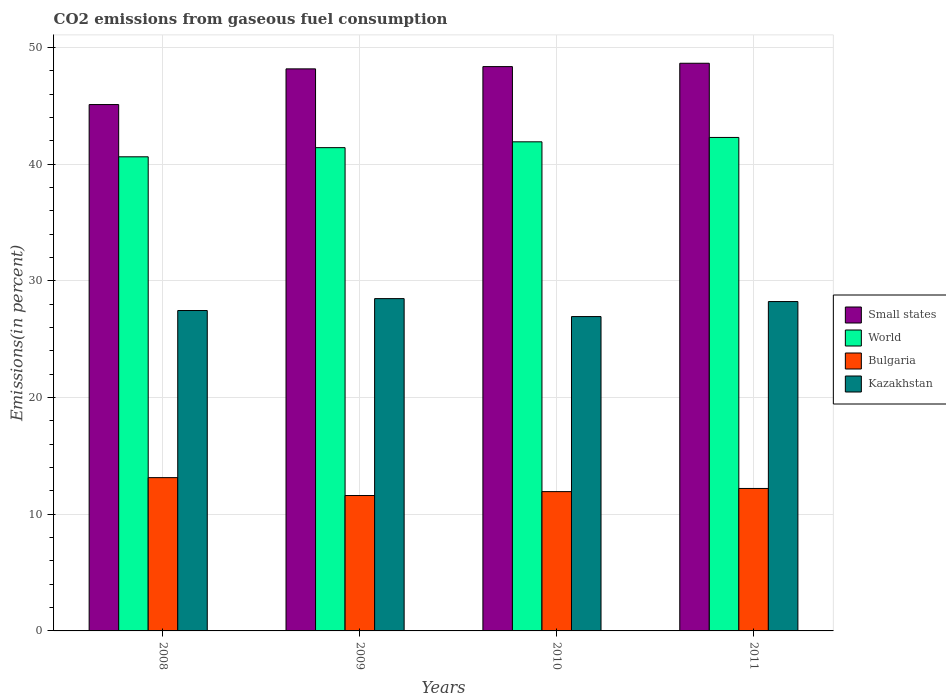Are the number of bars per tick equal to the number of legend labels?
Your answer should be compact. Yes. In how many cases, is the number of bars for a given year not equal to the number of legend labels?
Your response must be concise. 0. What is the total CO2 emitted in Kazakhstan in 2010?
Ensure brevity in your answer.  26.95. Across all years, what is the maximum total CO2 emitted in Small states?
Provide a short and direct response. 48.66. Across all years, what is the minimum total CO2 emitted in Bulgaria?
Provide a succinct answer. 11.61. What is the total total CO2 emitted in Kazakhstan in the graph?
Ensure brevity in your answer.  111.13. What is the difference between the total CO2 emitted in Bulgaria in 2008 and that in 2009?
Make the answer very short. 1.53. What is the difference between the total CO2 emitted in Bulgaria in 2008 and the total CO2 emitted in Kazakhstan in 2011?
Provide a short and direct response. -15.09. What is the average total CO2 emitted in Kazakhstan per year?
Provide a short and direct response. 27.78. In the year 2008, what is the difference between the total CO2 emitted in Bulgaria and total CO2 emitted in Small states?
Offer a very short reply. -31.98. In how many years, is the total CO2 emitted in Kazakhstan greater than 34 %?
Give a very brief answer. 0. What is the ratio of the total CO2 emitted in Kazakhstan in 2010 to that in 2011?
Make the answer very short. 0.95. Is the difference between the total CO2 emitted in Bulgaria in 2009 and 2010 greater than the difference between the total CO2 emitted in Small states in 2009 and 2010?
Ensure brevity in your answer.  No. What is the difference between the highest and the second highest total CO2 emitted in Bulgaria?
Your response must be concise. 0.93. What is the difference between the highest and the lowest total CO2 emitted in Small states?
Make the answer very short. 3.54. In how many years, is the total CO2 emitted in World greater than the average total CO2 emitted in World taken over all years?
Offer a terse response. 2. Is it the case that in every year, the sum of the total CO2 emitted in World and total CO2 emitted in Bulgaria is greater than the sum of total CO2 emitted in Kazakhstan and total CO2 emitted in Small states?
Provide a short and direct response. No. What does the 4th bar from the left in 2010 represents?
Provide a succinct answer. Kazakhstan. What does the 3rd bar from the right in 2009 represents?
Keep it short and to the point. World. Is it the case that in every year, the sum of the total CO2 emitted in Small states and total CO2 emitted in Kazakhstan is greater than the total CO2 emitted in World?
Give a very brief answer. Yes. Are all the bars in the graph horizontal?
Provide a short and direct response. No. What is the difference between two consecutive major ticks on the Y-axis?
Provide a succinct answer. 10. Are the values on the major ticks of Y-axis written in scientific E-notation?
Give a very brief answer. No. Does the graph contain any zero values?
Your answer should be very brief. No. How many legend labels are there?
Offer a very short reply. 4. How are the legend labels stacked?
Your answer should be compact. Vertical. What is the title of the graph?
Your answer should be compact. CO2 emissions from gaseous fuel consumption. What is the label or title of the X-axis?
Ensure brevity in your answer.  Years. What is the label or title of the Y-axis?
Give a very brief answer. Emissions(in percent). What is the Emissions(in percent) in Small states in 2008?
Keep it short and to the point. 45.12. What is the Emissions(in percent) of World in 2008?
Ensure brevity in your answer.  40.64. What is the Emissions(in percent) of Bulgaria in 2008?
Provide a short and direct response. 13.14. What is the Emissions(in percent) in Kazakhstan in 2008?
Offer a terse response. 27.46. What is the Emissions(in percent) in Small states in 2009?
Offer a terse response. 48.18. What is the Emissions(in percent) in World in 2009?
Ensure brevity in your answer.  41.43. What is the Emissions(in percent) in Bulgaria in 2009?
Offer a terse response. 11.61. What is the Emissions(in percent) in Kazakhstan in 2009?
Provide a short and direct response. 28.48. What is the Emissions(in percent) in Small states in 2010?
Your answer should be very brief. 48.37. What is the Emissions(in percent) of World in 2010?
Keep it short and to the point. 41.93. What is the Emissions(in percent) of Bulgaria in 2010?
Provide a short and direct response. 11.94. What is the Emissions(in percent) in Kazakhstan in 2010?
Your response must be concise. 26.95. What is the Emissions(in percent) in Small states in 2011?
Provide a short and direct response. 48.66. What is the Emissions(in percent) in World in 2011?
Give a very brief answer. 42.3. What is the Emissions(in percent) in Bulgaria in 2011?
Keep it short and to the point. 12.21. What is the Emissions(in percent) of Kazakhstan in 2011?
Provide a succinct answer. 28.23. Across all years, what is the maximum Emissions(in percent) of Small states?
Your answer should be compact. 48.66. Across all years, what is the maximum Emissions(in percent) of World?
Your response must be concise. 42.3. Across all years, what is the maximum Emissions(in percent) in Bulgaria?
Keep it short and to the point. 13.14. Across all years, what is the maximum Emissions(in percent) in Kazakhstan?
Offer a terse response. 28.48. Across all years, what is the minimum Emissions(in percent) of Small states?
Ensure brevity in your answer.  45.12. Across all years, what is the minimum Emissions(in percent) of World?
Ensure brevity in your answer.  40.64. Across all years, what is the minimum Emissions(in percent) in Bulgaria?
Offer a very short reply. 11.61. Across all years, what is the minimum Emissions(in percent) in Kazakhstan?
Make the answer very short. 26.95. What is the total Emissions(in percent) in Small states in the graph?
Your response must be concise. 190.33. What is the total Emissions(in percent) of World in the graph?
Your response must be concise. 166.29. What is the total Emissions(in percent) of Bulgaria in the graph?
Your answer should be very brief. 48.9. What is the total Emissions(in percent) of Kazakhstan in the graph?
Ensure brevity in your answer.  111.13. What is the difference between the Emissions(in percent) of Small states in 2008 and that in 2009?
Ensure brevity in your answer.  -3.06. What is the difference between the Emissions(in percent) in World in 2008 and that in 2009?
Provide a short and direct response. -0.78. What is the difference between the Emissions(in percent) of Bulgaria in 2008 and that in 2009?
Give a very brief answer. 1.53. What is the difference between the Emissions(in percent) in Kazakhstan in 2008 and that in 2009?
Make the answer very short. -1.02. What is the difference between the Emissions(in percent) of Small states in 2008 and that in 2010?
Your answer should be very brief. -3.25. What is the difference between the Emissions(in percent) in World in 2008 and that in 2010?
Your answer should be very brief. -1.28. What is the difference between the Emissions(in percent) of Bulgaria in 2008 and that in 2010?
Offer a very short reply. 1.2. What is the difference between the Emissions(in percent) in Kazakhstan in 2008 and that in 2010?
Your answer should be very brief. 0.52. What is the difference between the Emissions(in percent) in Small states in 2008 and that in 2011?
Ensure brevity in your answer.  -3.54. What is the difference between the Emissions(in percent) in World in 2008 and that in 2011?
Provide a succinct answer. -1.66. What is the difference between the Emissions(in percent) in Bulgaria in 2008 and that in 2011?
Offer a very short reply. 0.93. What is the difference between the Emissions(in percent) of Kazakhstan in 2008 and that in 2011?
Make the answer very short. -0.77. What is the difference between the Emissions(in percent) in Small states in 2009 and that in 2010?
Your answer should be very brief. -0.19. What is the difference between the Emissions(in percent) of World in 2009 and that in 2010?
Offer a terse response. -0.5. What is the difference between the Emissions(in percent) of Bulgaria in 2009 and that in 2010?
Provide a succinct answer. -0.34. What is the difference between the Emissions(in percent) in Kazakhstan in 2009 and that in 2010?
Offer a terse response. 1.54. What is the difference between the Emissions(in percent) of Small states in 2009 and that in 2011?
Make the answer very short. -0.48. What is the difference between the Emissions(in percent) in World in 2009 and that in 2011?
Offer a terse response. -0.88. What is the difference between the Emissions(in percent) of Bulgaria in 2009 and that in 2011?
Make the answer very short. -0.61. What is the difference between the Emissions(in percent) in Kazakhstan in 2009 and that in 2011?
Offer a very short reply. 0.25. What is the difference between the Emissions(in percent) in Small states in 2010 and that in 2011?
Ensure brevity in your answer.  -0.29. What is the difference between the Emissions(in percent) of World in 2010 and that in 2011?
Ensure brevity in your answer.  -0.38. What is the difference between the Emissions(in percent) of Bulgaria in 2010 and that in 2011?
Your response must be concise. -0.27. What is the difference between the Emissions(in percent) in Kazakhstan in 2010 and that in 2011?
Offer a very short reply. -1.29. What is the difference between the Emissions(in percent) in Small states in 2008 and the Emissions(in percent) in World in 2009?
Give a very brief answer. 3.69. What is the difference between the Emissions(in percent) in Small states in 2008 and the Emissions(in percent) in Bulgaria in 2009?
Your answer should be very brief. 33.51. What is the difference between the Emissions(in percent) in Small states in 2008 and the Emissions(in percent) in Kazakhstan in 2009?
Offer a terse response. 16.64. What is the difference between the Emissions(in percent) in World in 2008 and the Emissions(in percent) in Bulgaria in 2009?
Make the answer very short. 29.03. What is the difference between the Emissions(in percent) in World in 2008 and the Emissions(in percent) in Kazakhstan in 2009?
Keep it short and to the point. 12.16. What is the difference between the Emissions(in percent) of Bulgaria in 2008 and the Emissions(in percent) of Kazakhstan in 2009?
Offer a terse response. -15.35. What is the difference between the Emissions(in percent) in Small states in 2008 and the Emissions(in percent) in World in 2010?
Ensure brevity in your answer.  3.19. What is the difference between the Emissions(in percent) in Small states in 2008 and the Emissions(in percent) in Bulgaria in 2010?
Offer a terse response. 33.18. What is the difference between the Emissions(in percent) of Small states in 2008 and the Emissions(in percent) of Kazakhstan in 2010?
Provide a succinct answer. 18.17. What is the difference between the Emissions(in percent) in World in 2008 and the Emissions(in percent) in Bulgaria in 2010?
Give a very brief answer. 28.7. What is the difference between the Emissions(in percent) in World in 2008 and the Emissions(in percent) in Kazakhstan in 2010?
Keep it short and to the point. 13.69. What is the difference between the Emissions(in percent) of Bulgaria in 2008 and the Emissions(in percent) of Kazakhstan in 2010?
Offer a very short reply. -13.81. What is the difference between the Emissions(in percent) in Small states in 2008 and the Emissions(in percent) in World in 2011?
Give a very brief answer. 2.82. What is the difference between the Emissions(in percent) of Small states in 2008 and the Emissions(in percent) of Bulgaria in 2011?
Ensure brevity in your answer.  32.91. What is the difference between the Emissions(in percent) in Small states in 2008 and the Emissions(in percent) in Kazakhstan in 2011?
Give a very brief answer. 16.89. What is the difference between the Emissions(in percent) of World in 2008 and the Emissions(in percent) of Bulgaria in 2011?
Provide a short and direct response. 28.43. What is the difference between the Emissions(in percent) in World in 2008 and the Emissions(in percent) in Kazakhstan in 2011?
Keep it short and to the point. 12.41. What is the difference between the Emissions(in percent) in Bulgaria in 2008 and the Emissions(in percent) in Kazakhstan in 2011?
Your answer should be compact. -15.09. What is the difference between the Emissions(in percent) in Small states in 2009 and the Emissions(in percent) in World in 2010?
Ensure brevity in your answer.  6.25. What is the difference between the Emissions(in percent) of Small states in 2009 and the Emissions(in percent) of Bulgaria in 2010?
Your response must be concise. 36.24. What is the difference between the Emissions(in percent) of Small states in 2009 and the Emissions(in percent) of Kazakhstan in 2010?
Offer a terse response. 21.23. What is the difference between the Emissions(in percent) of World in 2009 and the Emissions(in percent) of Bulgaria in 2010?
Keep it short and to the point. 29.48. What is the difference between the Emissions(in percent) of World in 2009 and the Emissions(in percent) of Kazakhstan in 2010?
Offer a very short reply. 14.48. What is the difference between the Emissions(in percent) in Bulgaria in 2009 and the Emissions(in percent) in Kazakhstan in 2010?
Provide a succinct answer. -15.34. What is the difference between the Emissions(in percent) in Small states in 2009 and the Emissions(in percent) in World in 2011?
Ensure brevity in your answer.  5.88. What is the difference between the Emissions(in percent) in Small states in 2009 and the Emissions(in percent) in Bulgaria in 2011?
Offer a very short reply. 35.97. What is the difference between the Emissions(in percent) of Small states in 2009 and the Emissions(in percent) of Kazakhstan in 2011?
Your answer should be compact. 19.95. What is the difference between the Emissions(in percent) in World in 2009 and the Emissions(in percent) in Bulgaria in 2011?
Provide a succinct answer. 29.21. What is the difference between the Emissions(in percent) of World in 2009 and the Emissions(in percent) of Kazakhstan in 2011?
Make the answer very short. 13.19. What is the difference between the Emissions(in percent) in Bulgaria in 2009 and the Emissions(in percent) in Kazakhstan in 2011?
Your answer should be compact. -16.63. What is the difference between the Emissions(in percent) of Small states in 2010 and the Emissions(in percent) of World in 2011?
Keep it short and to the point. 6.07. What is the difference between the Emissions(in percent) of Small states in 2010 and the Emissions(in percent) of Bulgaria in 2011?
Provide a succinct answer. 36.16. What is the difference between the Emissions(in percent) of Small states in 2010 and the Emissions(in percent) of Kazakhstan in 2011?
Your answer should be compact. 20.14. What is the difference between the Emissions(in percent) of World in 2010 and the Emissions(in percent) of Bulgaria in 2011?
Your response must be concise. 29.71. What is the difference between the Emissions(in percent) of World in 2010 and the Emissions(in percent) of Kazakhstan in 2011?
Give a very brief answer. 13.69. What is the difference between the Emissions(in percent) in Bulgaria in 2010 and the Emissions(in percent) in Kazakhstan in 2011?
Ensure brevity in your answer.  -16.29. What is the average Emissions(in percent) in Small states per year?
Offer a terse response. 47.58. What is the average Emissions(in percent) of World per year?
Keep it short and to the point. 41.57. What is the average Emissions(in percent) in Bulgaria per year?
Offer a very short reply. 12.22. What is the average Emissions(in percent) in Kazakhstan per year?
Your response must be concise. 27.78. In the year 2008, what is the difference between the Emissions(in percent) of Small states and Emissions(in percent) of World?
Give a very brief answer. 4.48. In the year 2008, what is the difference between the Emissions(in percent) of Small states and Emissions(in percent) of Bulgaria?
Your answer should be compact. 31.98. In the year 2008, what is the difference between the Emissions(in percent) in Small states and Emissions(in percent) in Kazakhstan?
Offer a very short reply. 17.66. In the year 2008, what is the difference between the Emissions(in percent) in World and Emissions(in percent) in Bulgaria?
Provide a short and direct response. 27.5. In the year 2008, what is the difference between the Emissions(in percent) in World and Emissions(in percent) in Kazakhstan?
Keep it short and to the point. 13.18. In the year 2008, what is the difference between the Emissions(in percent) of Bulgaria and Emissions(in percent) of Kazakhstan?
Give a very brief answer. -14.32. In the year 2009, what is the difference between the Emissions(in percent) in Small states and Emissions(in percent) in World?
Your answer should be compact. 6.75. In the year 2009, what is the difference between the Emissions(in percent) in Small states and Emissions(in percent) in Bulgaria?
Offer a very short reply. 36.57. In the year 2009, what is the difference between the Emissions(in percent) in Small states and Emissions(in percent) in Kazakhstan?
Offer a terse response. 19.69. In the year 2009, what is the difference between the Emissions(in percent) of World and Emissions(in percent) of Bulgaria?
Your response must be concise. 29.82. In the year 2009, what is the difference between the Emissions(in percent) in World and Emissions(in percent) in Kazakhstan?
Make the answer very short. 12.94. In the year 2009, what is the difference between the Emissions(in percent) of Bulgaria and Emissions(in percent) of Kazakhstan?
Give a very brief answer. -16.88. In the year 2010, what is the difference between the Emissions(in percent) in Small states and Emissions(in percent) in World?
Your answer should be very brief. 6.45. In the year 2010, what is the difference between the Emissions(in percent) in Small states and Emissions(in percent) in Bulgaria?
Offer a very short reply. 36.43. In the year 2010, what is the difference between the Emissions(in percent) in Small states and Emissions(in percent) in Kazakhstan?
Offer a terse response. 21.43. In the year 2010, what is the difference between the Emissions(in percent) of World and Emissions(in percent) of Bulgaria?
Your answer should be very brief. 29.98. In the year 2010, what is the difference between the Emissions(in percent) in World and Emissions(in percent) in Kazakhstan?
Your answer should be compact. 14.98. In the year 2010, what is the difference between the Emissions(in percent) in Bulgaria and Emissions(in percent) in Kazakhstan?
Make the answer very short. -15.01. In the year 2011, what is the difference between the Emissions(in percent) of Small states and Emissions(in percent) of World?
Provide a succinct answer. 6.36. In the year 2011, what is the difference between the Emissions(in percent) of Small states and Emissions(in percent) of Bulgaria?
Offer a very short reply. 36.45. In the year 2011, what is the difference between the Emissions(in percent) in Small states and Emissions(in percent) in Kazakhstan?
Offer a very short reply. 20.43. In the year 2011, what is the difference between the Emissions(in percent) in World and Emissions(in percent) in Bulgaria?
Your answer should be compact. 30.09. In the year 2011, what is the difference between the Emissions(in percent) of World and Emissions(in percent) of Kazakhstan?
Offer a terse response. 14.07. In the year 2011, what is the difference between the Emissions(in percent) of Bulgaria and Emissions(in percent) of Kazakhstan?
Ensure brevity in your answer.  -16.02. What is the ratio of the Emissions(in percent) in Small states in 2008 to that in 2009?
Ensure brevity in your answer.  0.94. What is the ratio of the Emissions(in percent) of World in 2008 to that in 2009?
Offer a very short reply. 0.98. What is the ratio of the Emissions(in percent) of Bulgaria in 2008 to that in 2009?
Offer a very short reply. 1.13. What is the ratio of the Emissions(in percent) of Kazakhstan in 2008 to that in 2009?
Provide a succinct answer. 0.96. What is the ratio of the Emissions(in percent) in Small states in 2008 to that in 2010?
Provide a succinct answer. 0.93. What is the ratio of the Emissions(in percent) in World in 2008 to that in 2010?
Offer a terse response. 0.97. What is the ratio of the Emissions(in percent) in Bulgaria in 2008 to that in 2010?
Your response must be concise. 1.1. What is the ratio of the Emissions(in percent) in Kazakhstan in 2008 to that in 2010?
Make the answer very short. 1.02. What is the ratio of the Emissions(in percent) in Small states in 2008 to that in 2011?
Give a very brief answer. 0.93. What is the ratio of the Emissions(in percent) of World in 2008 to that in 2011?
Offer a terse response. 0.96. What is the ratio of the Emissions(in percent) in Bulgaria in 2008 to that in 2011?
Offer a terse response. 1.08. What is the ratio of the Emissions(in percent) of Kazakhstan in 2008 to that in 2011?
Ensure brevity in your answer.  0.97. What is the ratio of the Emissions(in percent) in Bulgaria in 2009 to that in 2010?
Ensure brevity in your answer.  0.97. What is the ratio of the Emissions(in percent) of Kazakhstan in 2009 to that in 2010?
Give a very brief answer. 1.06. What is the ratio of the Emissions(in percent) in Small states in 2009 to that in 2011?
Your answer should be very brief. 0.99. What is the ratio of the Emissions(in percent) of World in 2009 to that in 2011?
Make the answer very short. 0.98. What is the ratio of the Emissions(in percent) of Bulgaria in 2009 to that in 2011?
Provide a succinct answer. 0.95. What is the ratio of the Emissions(in percent) of Kazakhstan in 2009 to that in 2011?
Your response must be concise. 1.01. What is the ratio of the Emissions(in percent) in Small states in 2010 to that in 2011?
Offer a terse response. 0.99. What is the ratio of the Emissions(in percent) of World in 2010 to that in 2011?
Offer a terse response. 0.99. What is the ratio of the Emissions(in percent) in Bulgaria in 2010 to that in 2011?
Make the answer very short. 0.98. What is the ratio of the Emissions(in percent) in Kazakhstan in 2010 to that in 2011?
Ensure brevity in your answer.  0.95. What is the difference between the highest and the second highest Emissions(in percent) in Small states?
Your response must be concise. 0.29. What is the difference between the highest and the second highest Emissions(in percent) of World?
Provide a succinct answer. 0.38. What is the difference between the highest and the second highest Emissions(in percent) of Bulgaria?
Offer a terse response. 0.93. What is the difference between the highest and the second highest Emissions(in percent) in Kazakhstan?
Your answer should be compact. 0.25. What is the difference between the highest and the lowest Emissions(in percent) of Small states?
Make the answer very short. 3.54. What is the difference between the highest and the lowest Emissions(in percent) in World?
Give a very brief answer. 1.66. What is the difference between the highest and the lowest Emissions(in percent) in Bulgaria?
Offer a very short reply. 1.53. What is the difference between the highest and the lowest Emissions(in percent) of Kazakhstan?
Provide a short and direct response. 1.54. 